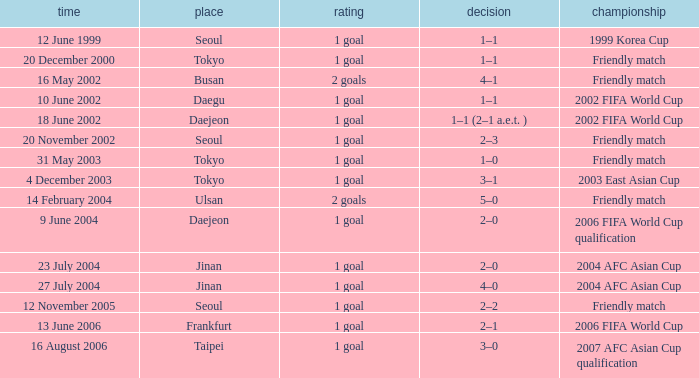What was the score of the game played on 16 August 2006? 1 goal. 